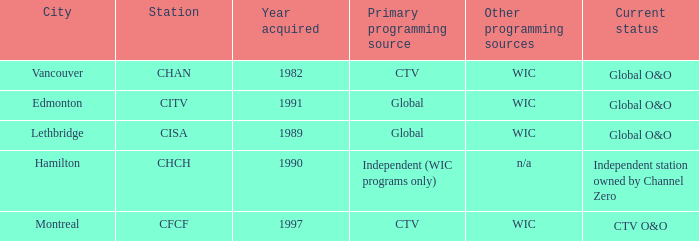How any were gained as the chan 1.0. 